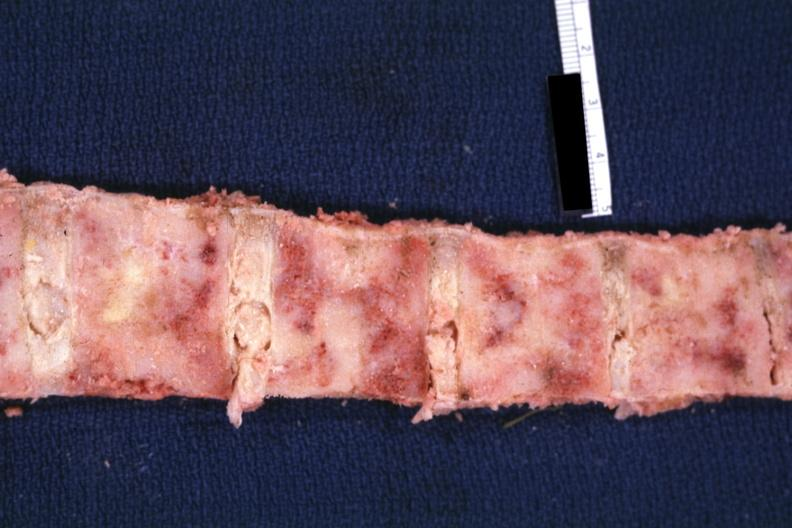what is lung?
Answer the question using a single word or phrase. Bone nearly completely filled with tumor primary 